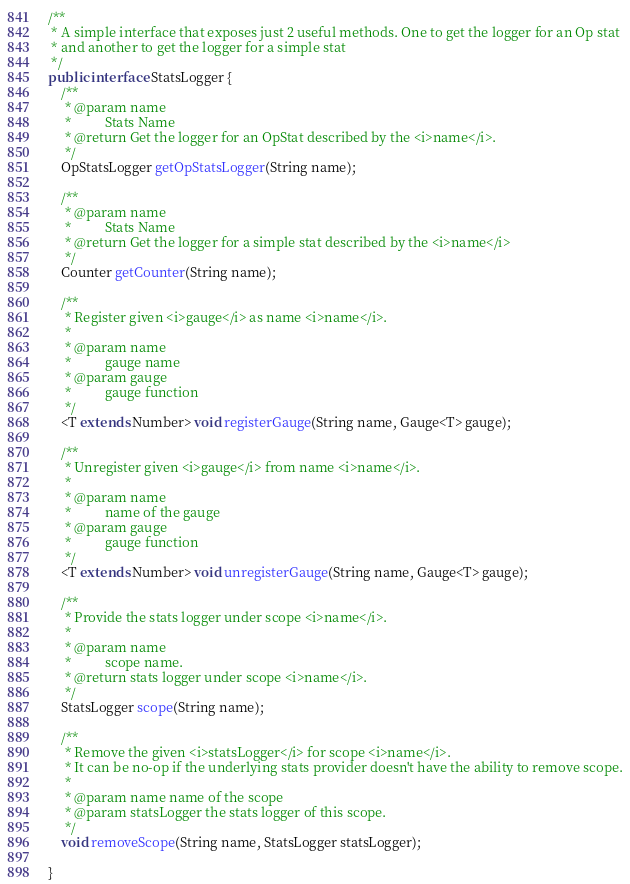Convert code to text. <code><loc_0><loc_0><loc_500><loc_500><_Java_>
/**
 * A simple interface that exposes just 2 useful methods. One to get the logger for an Op stat
 * and another to get the logger for a simple stat
 */
public interface StatsLogger {
    /**
     * @param name
     *          Stats Name
     * @return Get the logger for an OpStat described by the <i>name</i>.
     */
    OpStatsLogger getOpStatsLogger(String name);

    /**
     * @param name
     *          Stats Name
     * @return Get the logger for a simple stat described by the <i>name</i>
     */
    Counter getCounter(String name);

    /**
     * Register given <i>gauge</i> as name <i>name</i>.
     *
     * @param name
     *          gauge name
     * @param gauge
     *          gauge function
     */
    <T extends Number> void registerGauge(String name, Gauge<T> gauge);

    /**
     * Unregister given <i>gauge</i> from name <i>name</i>.
     *
     * @param name
     *          name of the gauge
     * @param gauge
     *          gauge function
     */
    <T extends Number> void unregisterGauge(String name, Gauge<T> gauge);

    /**
     * Provide the stats logger under scope <i>name</i>.
     *
     * @param name
     *          scope name.
     * @return stats logger under scope <i>name</i>.
     */
    StatsLogger scope(String name);

    /**
     * Remove the given <i>statsLogger</i> for scope <i>name</i>.
     * It can be no-op if the underlying stats provider doesn't have the ability to remove scope.
     *
     * @param name name of the scope
     * @param statsLogger the stats logger of this scope.
     */
    void removeScope(String name, StatsLogger statsLogger);

}
</code> 